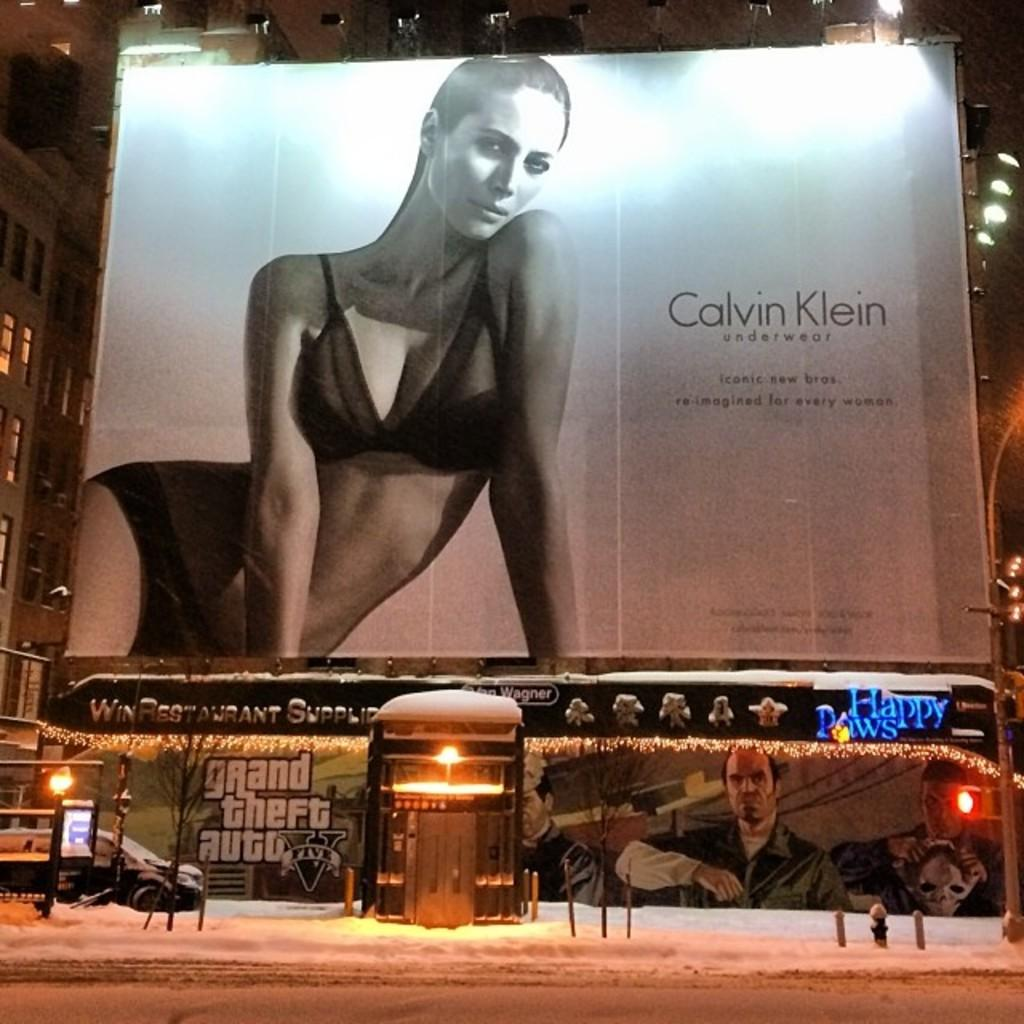<image>
Relay a brief, clear account of the picture shown. A Calvin Klein ad shows a woman in a bra and underwear. 